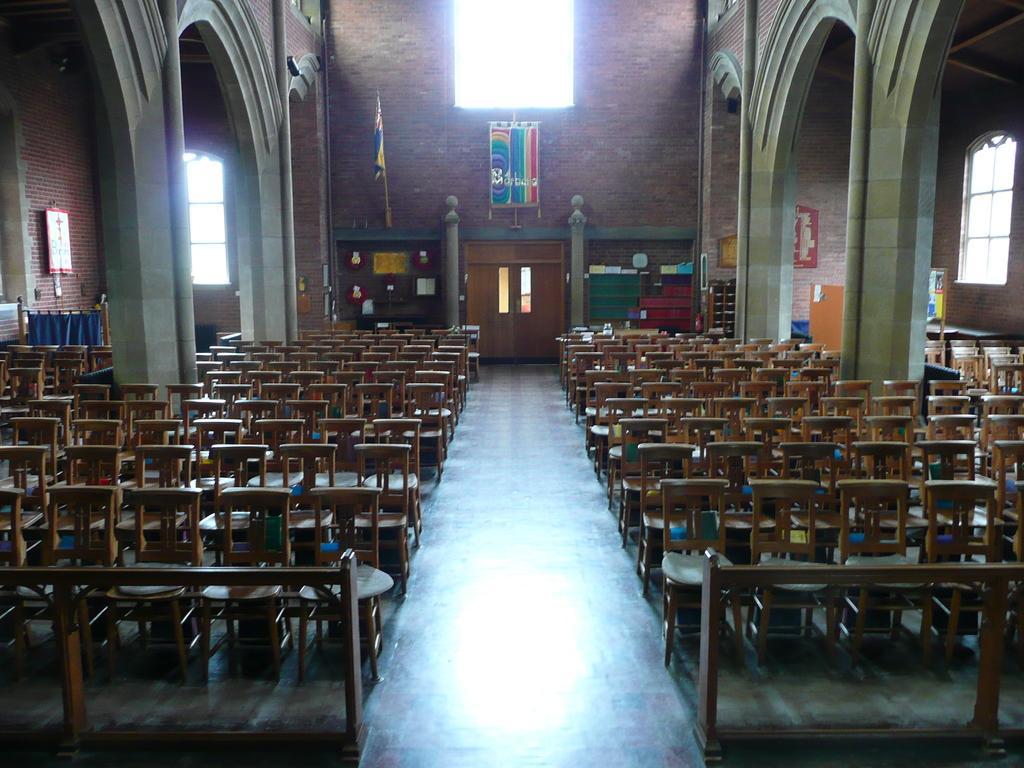Can you describe this image briefly? This picture is clicked inside. In the center we can see many number of wooden chairs. On both the sides we can see the arch. In the background there is a window, flag and a wooden door and some other items. 